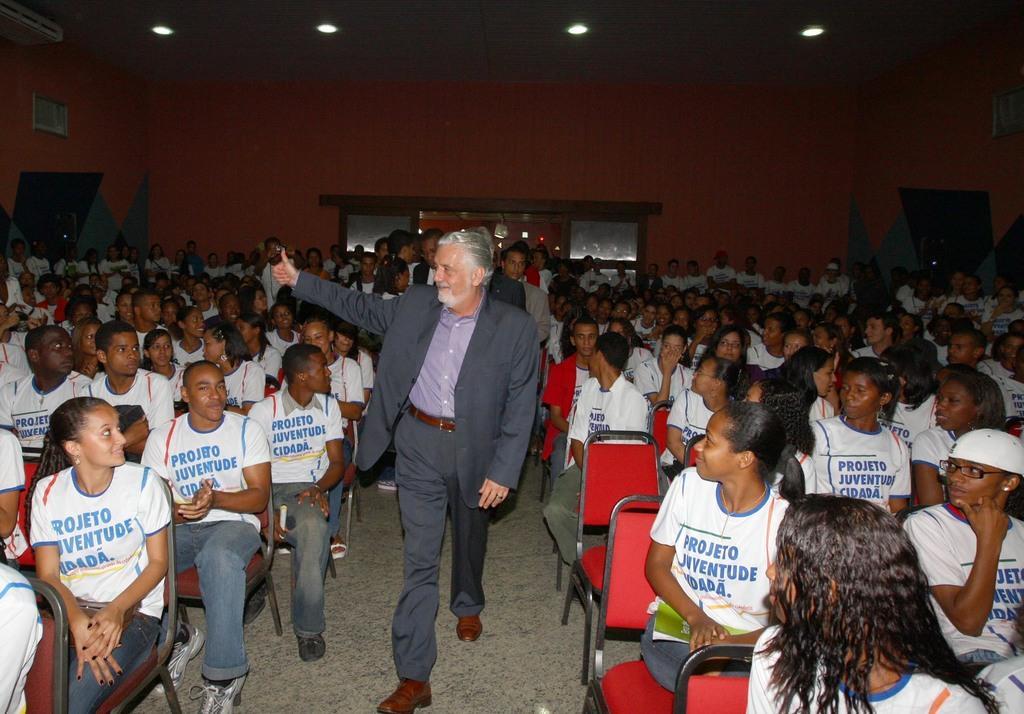Describe this image in one or two sentences. There is one person standing in the middle is wearing a blazer. There are some other persons sitting on the chairs in the background. There is a wall at the top of this image. 